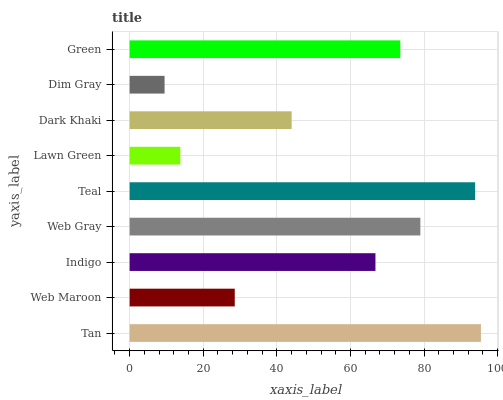Is Dim Gray the minimum?
Answer yes or no. Yes. Is Tan the maximum?
Answer yes or no. Yes. Is Web Maroon the minimum?
Answer yes or no. No. Is Web Maroon the maximum?
Answer yes or no. No. Is Tan greater than Web Maroon?
Answer yes or no. Yes. Is Web Maroon less than Tan?
Answer yes or no. Yes. Is Web Maroon greater than Tan?
Answer yes or no. No. Is Tan less than Web Maroon?
Answer yes or no. No. Is Indigo the high median?
Answer yes or no. Yes. Is Indigo the low median?
Answer yes or no. Yes. Is Teal the high median?
Answer yes or no. No. Is Teal the low median?
Answer yes or no. No. 